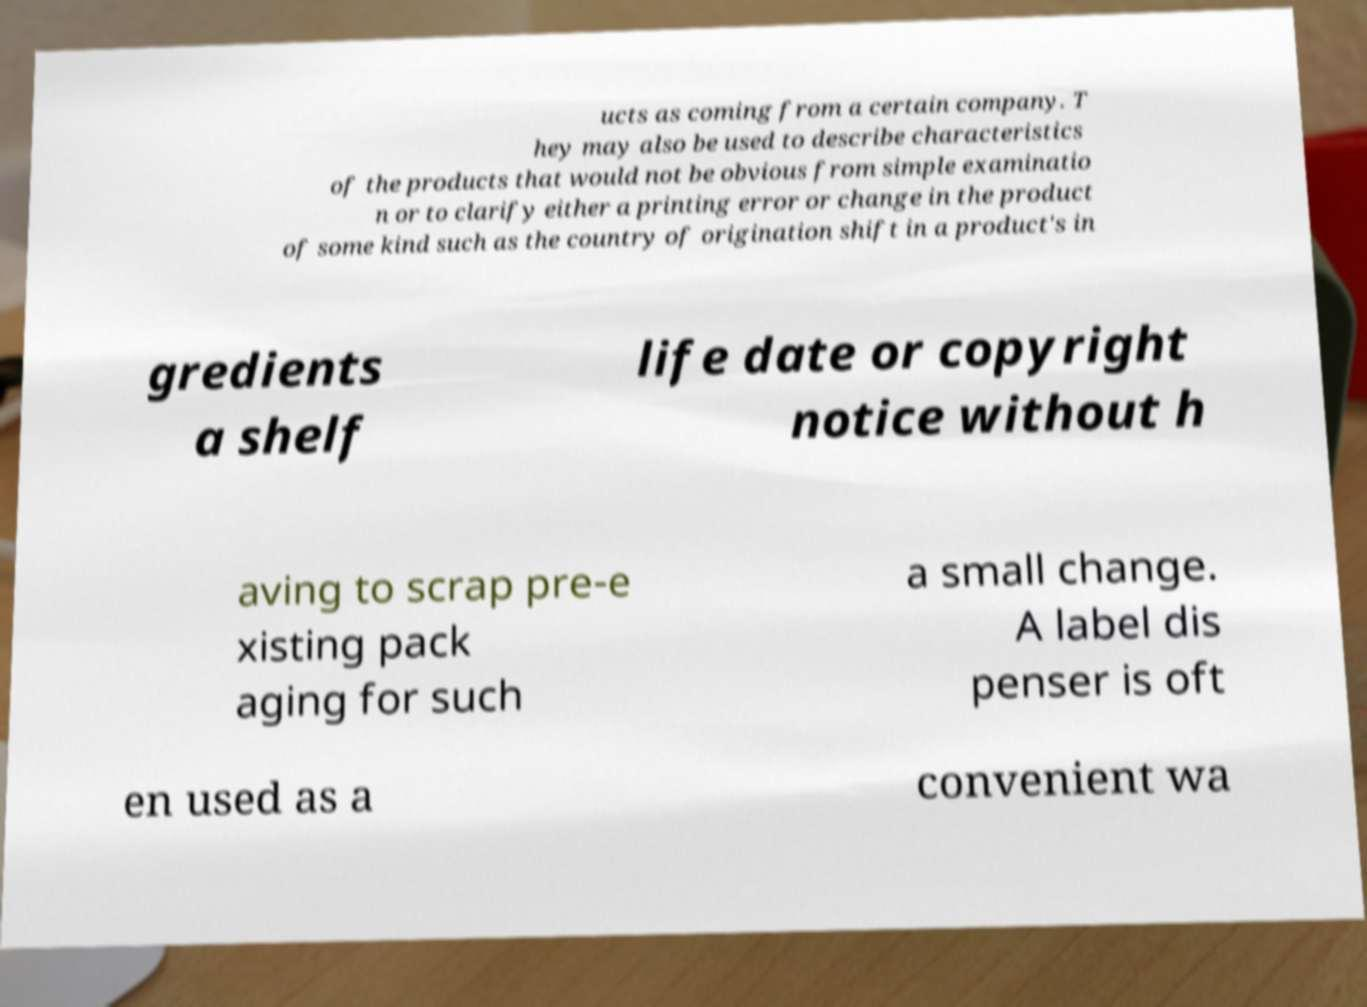Could you extract and type out the text from this image? ucts as coming from a certain company. T hey may also be used to describe characteristics of the products that would not be obvious from simple examinatio n or to clarify either a printing error or change in the product of some kind such as the country of origination shift in a product's in gredients a shelf life date or copyright notice without h aving to scrap pre-e xisting pack aging for such a small change. A label dis penser is oft en used as a convenient wa 